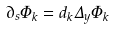Convert formula to latex. <formula><loc_0><loc_0><loc_500><loc_500>\partial _ { s } \Phi _ { k } = d _ { k } \Delta _ { y } \Phi _ { k }</formula> 